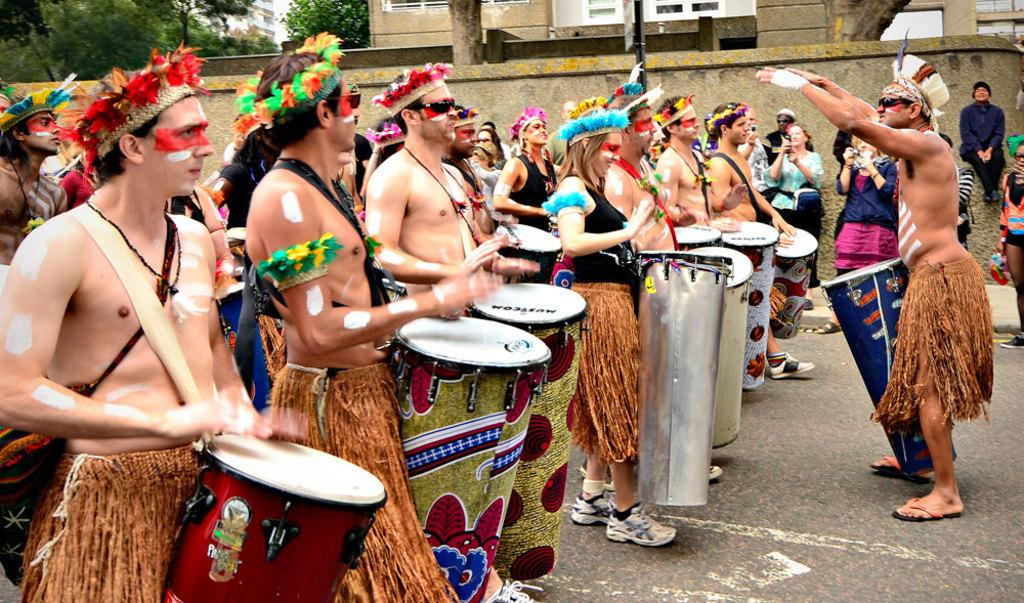What are the persons in the image doing? The persons in the image are playing musical drums. What can be seen in the background of the image? There is a road, a wall, a building, and trees in the image. What type of question is being asked by the cloud in the image? There are no clouds present in the image, and therefore no questions are being asked by a cloud. 